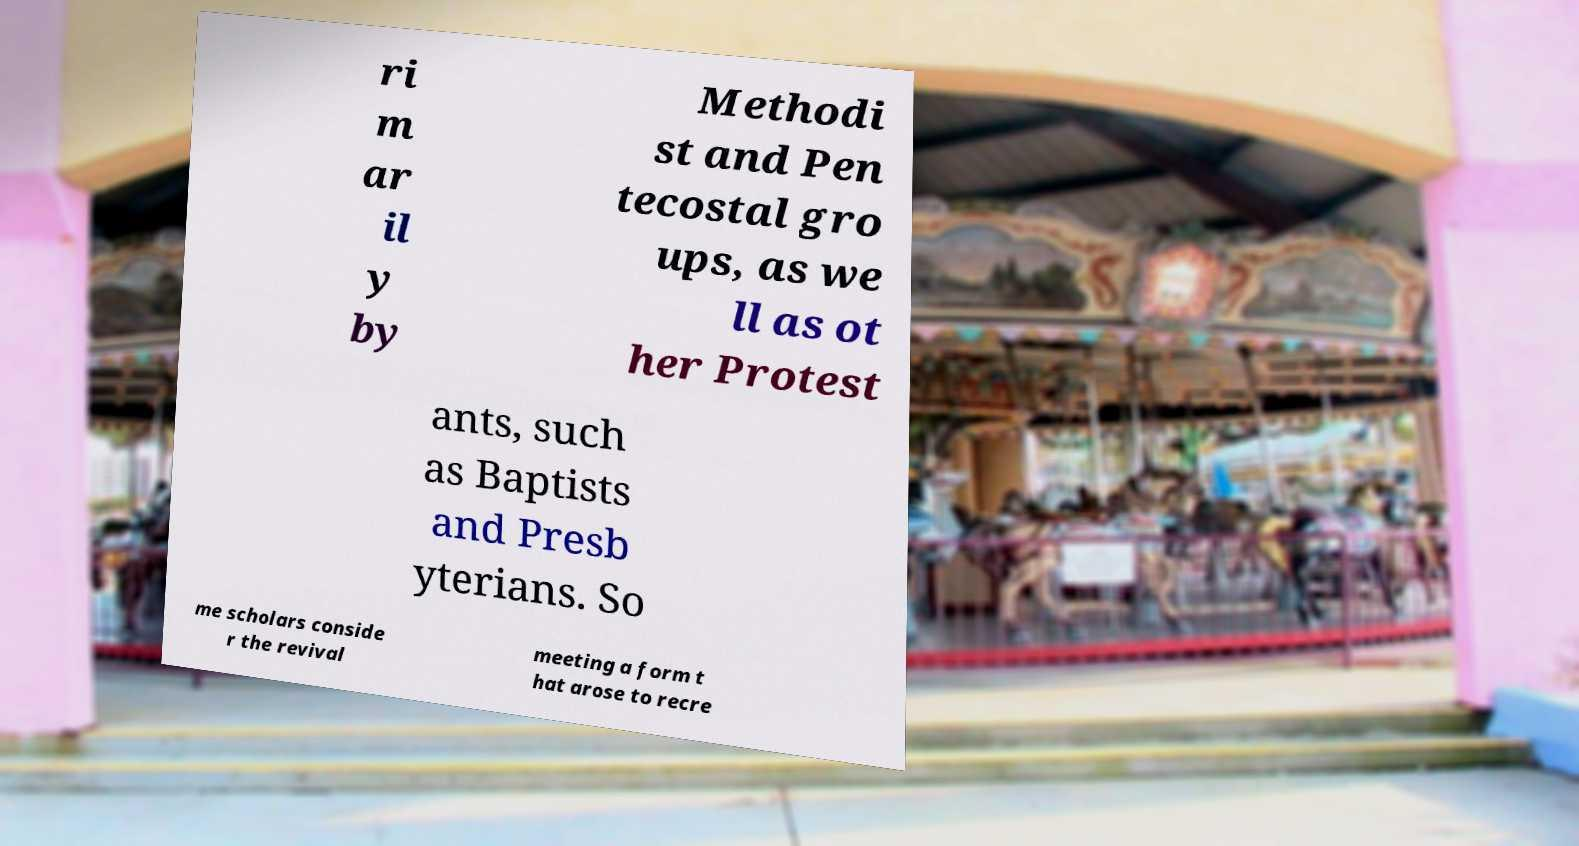Can you accurately transcribe the text from the provided image for me? ri m ar il y by Methodi st and Pen tecostal gro ups, as we ll as ot her Protest ants, such as Baptists and Presb yterians. So me scholars conside r the revival meeting a form t hat arose to recre 